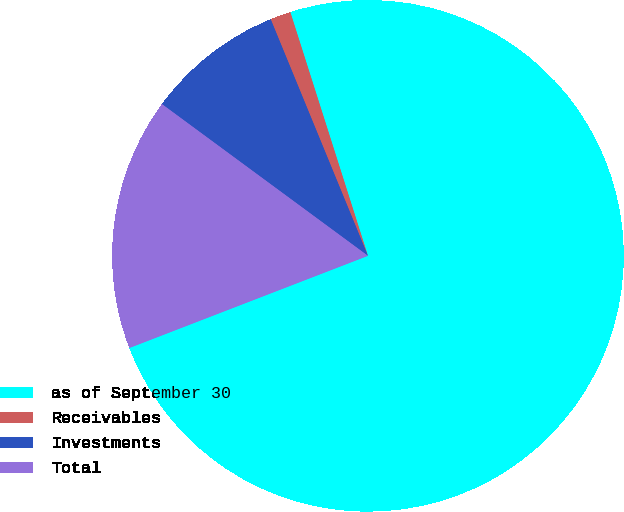Convert chart to OTSL. <chart><loc_0><loc_0><loc_500><loc_500><pie_chart><fcel>as of September 30<fcel>Receivables<fcel>Investments<fcel>Total<nl><fcel>74.04%<fcel>1.3%<fcel>8.69%<fcel>15.97%<nl></chart> 